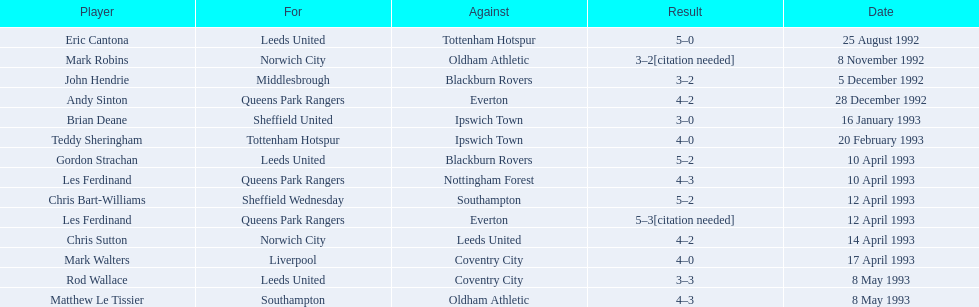Which player had the same result as mark robins? John Hendrie. 